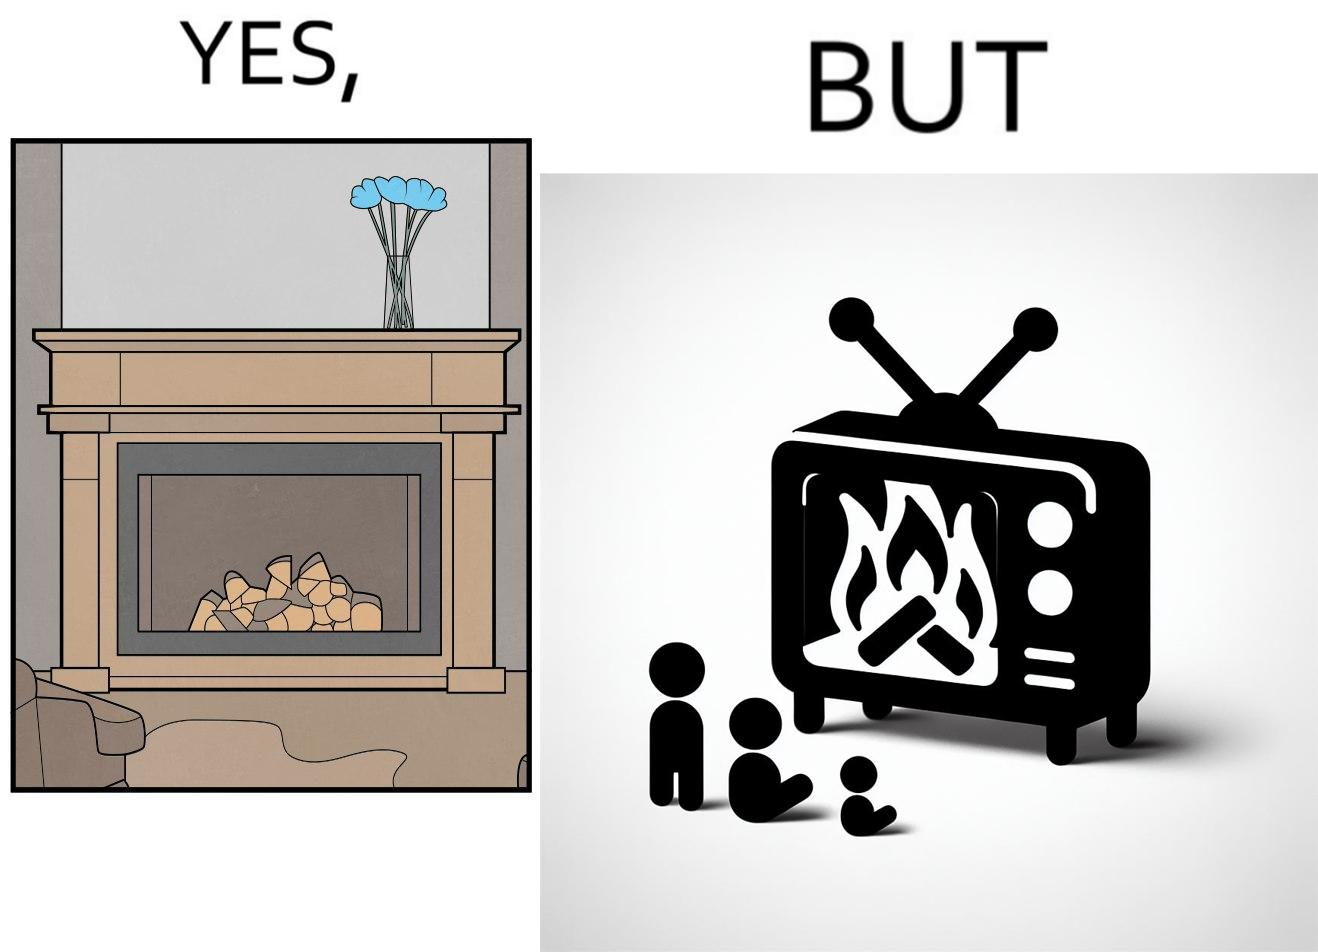Compare the left and right sides of this image. In the left part of the image: It is a fireplace In the right part of the image: It a fireplace being displayed on a television screen 